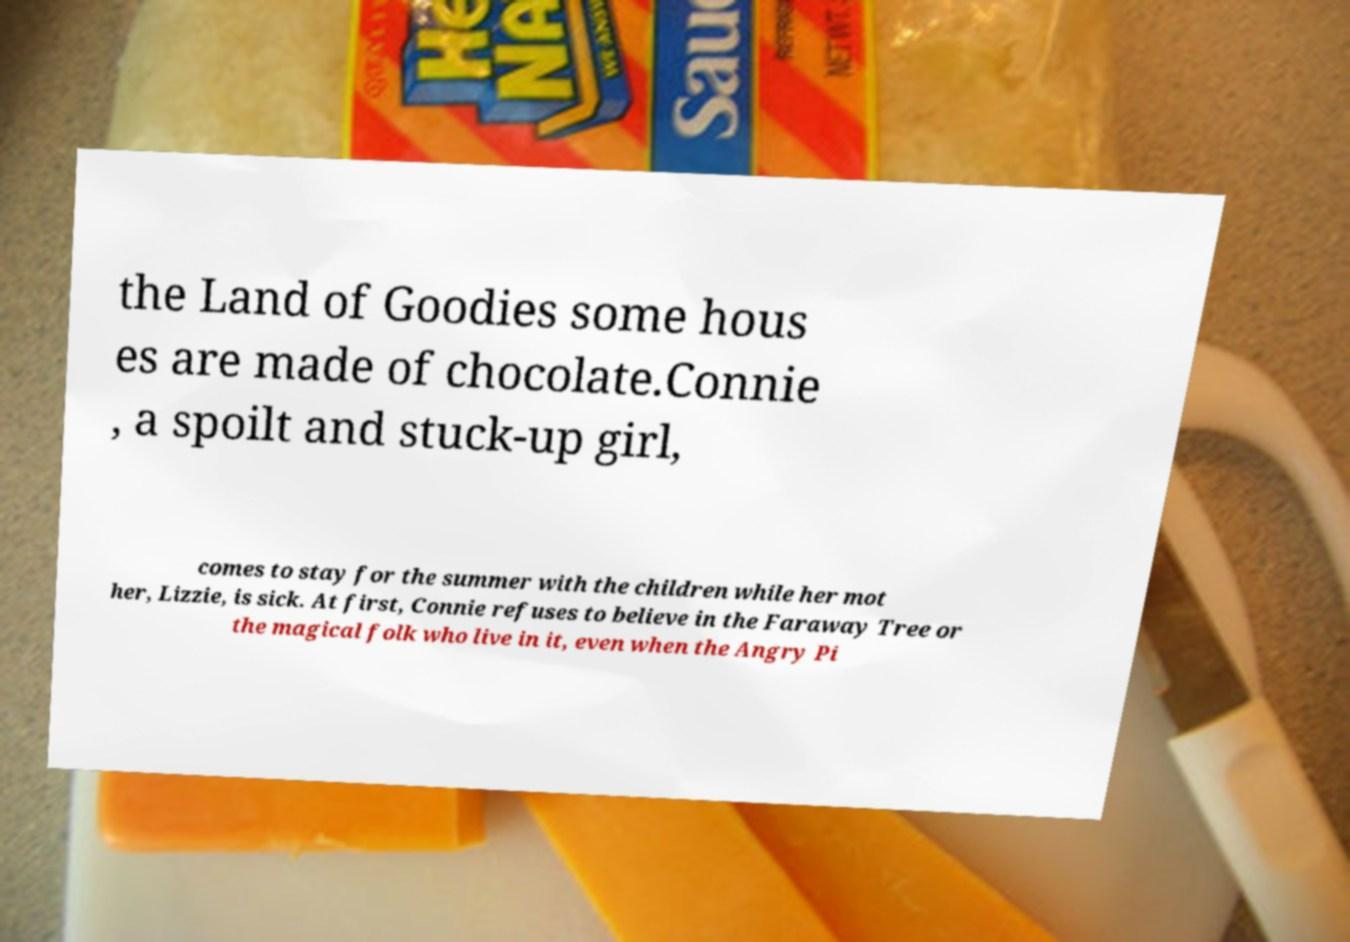Please identify and transcribe the text found in this image. the Land of Goodies some hous es are made of chocolate.Connie , a spoilt and stuck-up girl, comes to stay for the summer with the children while her mot her, Lizzie, is sick. At first, Connie refuses to believe in the Faraway Tree or the magical folk who live in it, even when the Angry Pi 